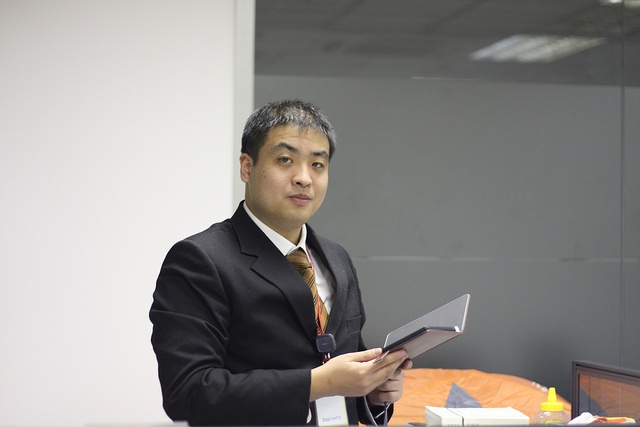Describe the objects in this image and their specific colors. I can see people in darkgray, black, gray, and tan tones, book in darkgray, gray, and black tones, book in darkgray, ivory, lightgray, and tan tones, tie in darkgray, black, lightgray, gray, and tan tones, and bottle in darkgray, tan, and yellow tones in this image. 